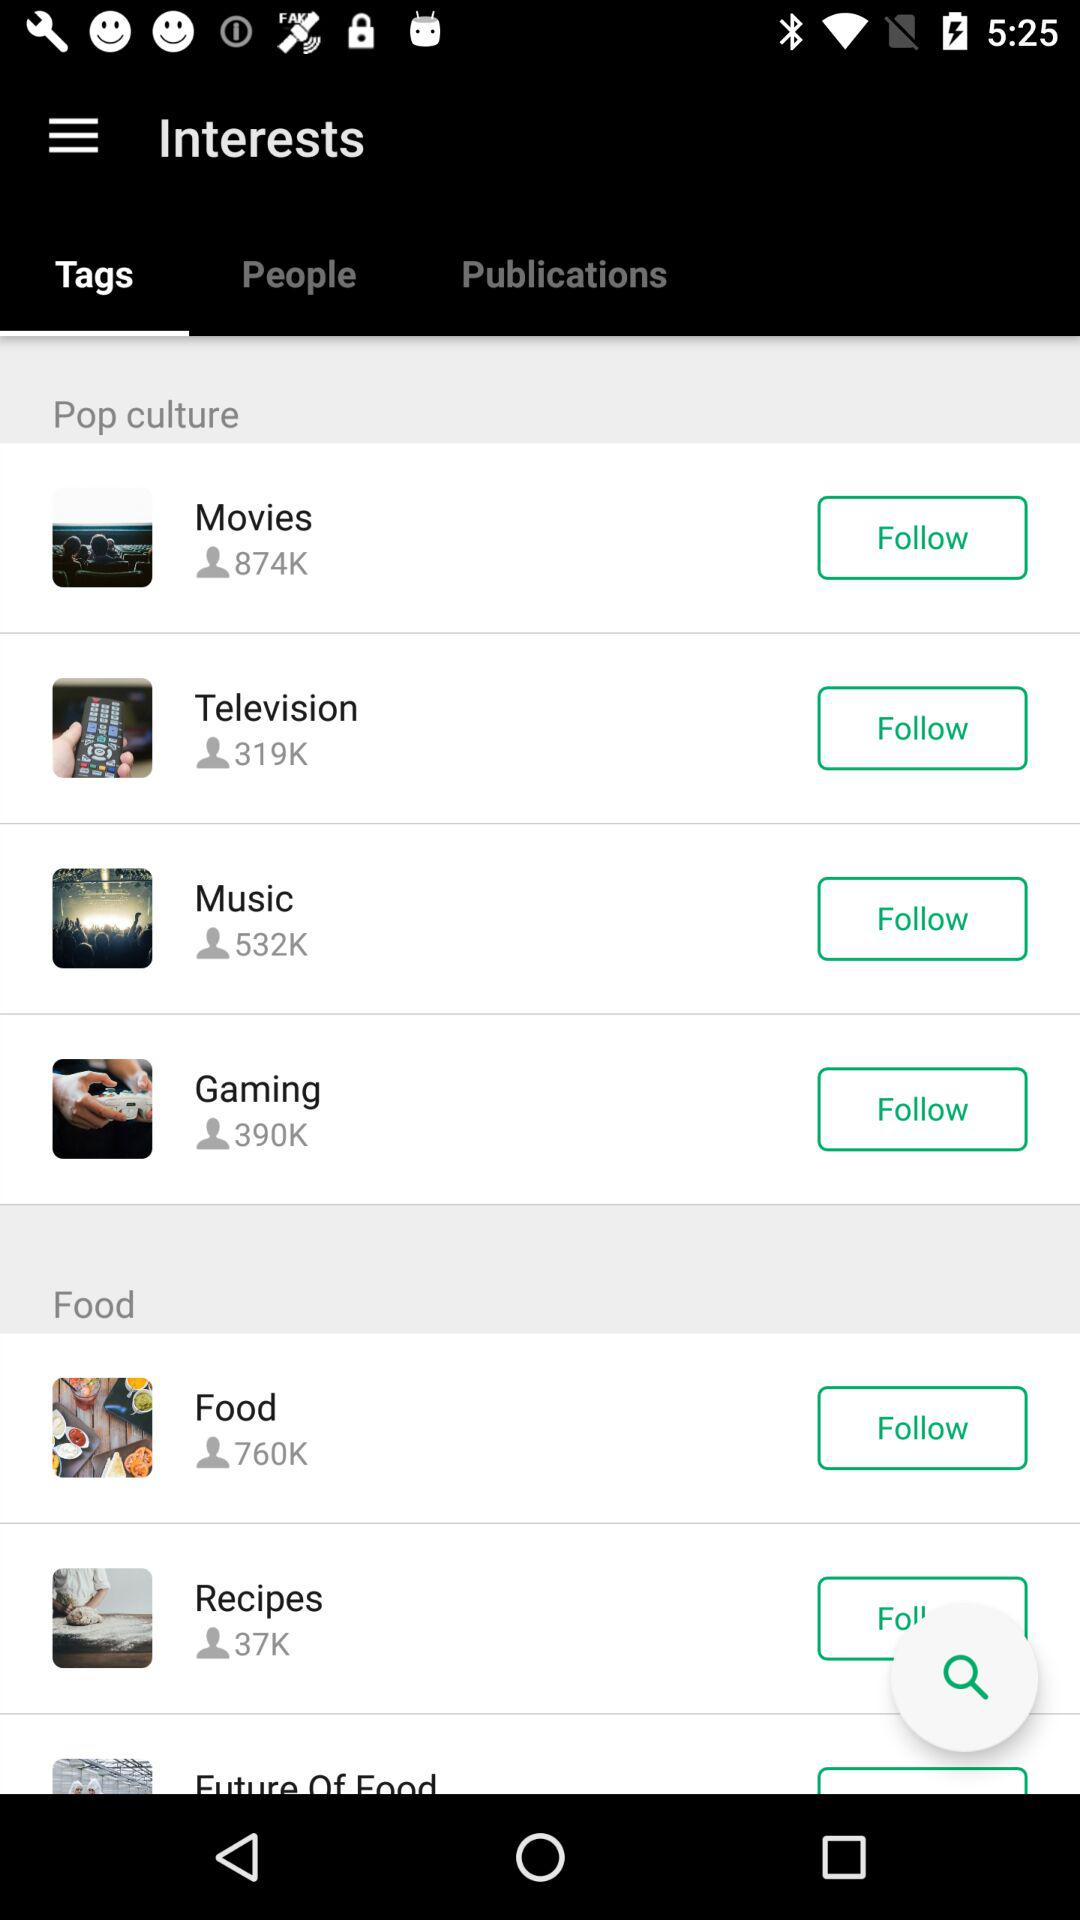Which option is selected for "Interests"? The selected option is "Tags". 